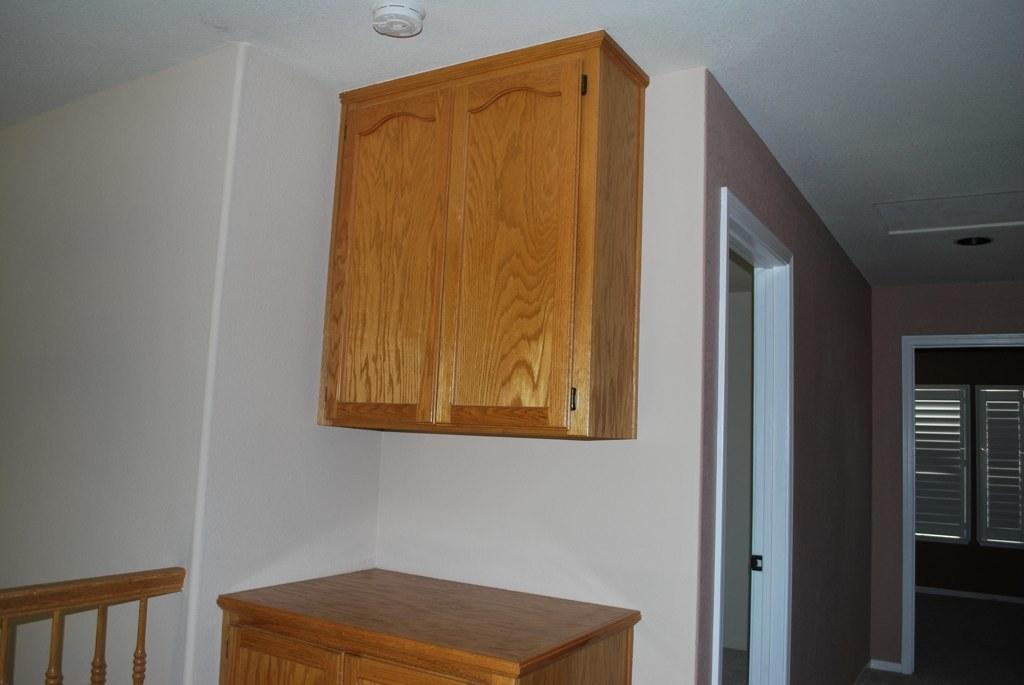Could you give a brief overview of what you see in this image? In the foreground of this image, there is a table and a cupboard to a wall. On the right, there are two entrances and a window blind in the background. On the left, there is a railing and a wall. 